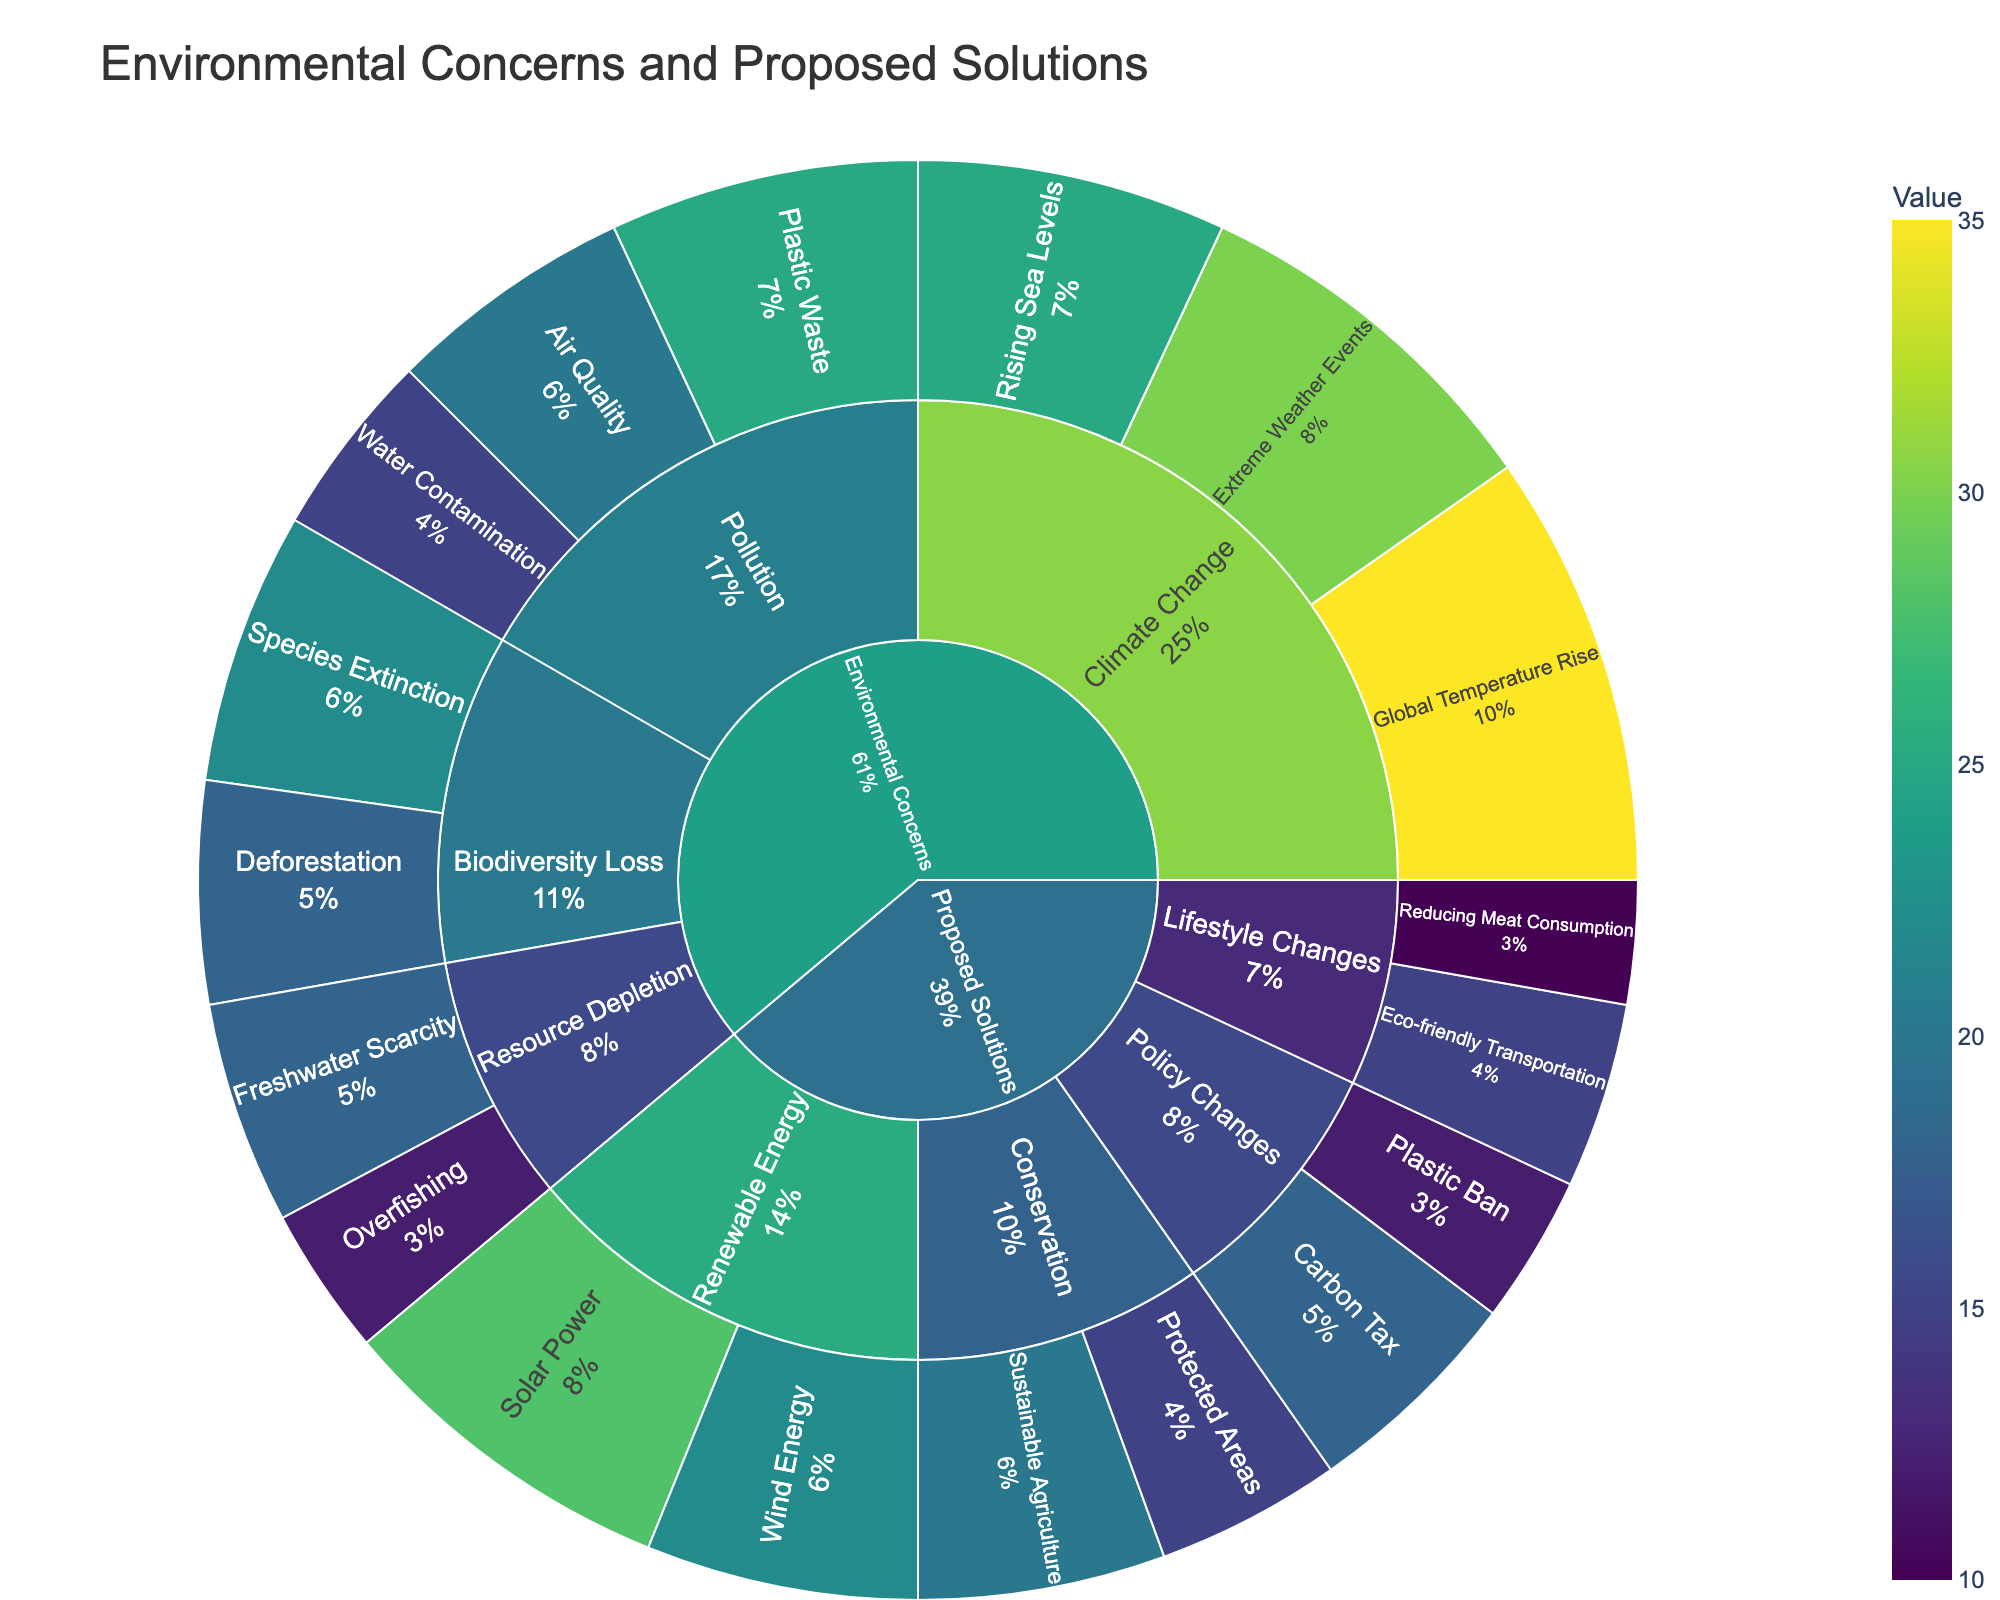What's the main topic in the central node? The Sunburst Plot's central node typically represents the highest-level category. Here, both 'Environmental Concerns' and 'Proposed Solutions' are shown, indicating these are the main overarching topics.
Answer: Environmental Concerns, Proposed Solutions Which issue under "Climate Change" has the highest value? Under the "Climate Change" subcategory, the "Global Temperature Rise" has the highest value noted on the Sunburst Plot.
Answer: Global Temperature Rise How many issues are represented under the "Pollution" subcategory? Visual inspection of the "Pollution" subcategory reveals that there are three issues: "Air Quality," "Water Contamination," and "Plastic Waste."
Answer: 3 What is the total value of the issues concerned with "Resource Depletion"? Issues under "Resource Depletion" include "Overfishing" and "Freshwater Scarcity." Summing up their values, we have 12 + 18 = 30.
Answer: 30 Among the proposed solutions, which category has the highest combined value? The proposed solutions can be categorized into "Renewable Energy," "Conservation," "Policy Changes," and "Lifestyle Changes." By summing values:
- Renewable Energy: 28 + 22 = 50
- Conservation: 15 + 20 = 35
- Policy Changes: 18 + 12 = 30
- Lifestyle Changes: 10 + 15 = 25
"Renewable Energy" has the highest combined value.
Answer: Renewable Energy What is the percentage contribution of "Extreme Weather Events" in the "Climate Change" subcategory? To find the percentage, divide the value of "Extreme Weather Events" by the total value of "Climate Change." Total value under "Climate Change" is 25 + 30 + 35 = 90. So, (30 / 90) * 100 = 33.33%.
Answer: 33.33% Compare the value of "Species Extinction" to "Deforestation" under "Biodiversity Loss." Which one is greater? Under "Biodiversity Loss," "Species Extinction" has a value of 22, while "Deforestation" has a value of 18. Thus, "Species Extinction" is greater.
Answer: Species Extinction What proposed solution has the lowest value? Among the proposed solutions, the lowest value is for "Reducing Meat Consumption" under "Lifestyle Changes," which has a value of 10.
Answer: Reducing Meat Consumption Which subcategory under "Proposed Solutions" has the smallest range of values? The subcategories and their value ranges:
- Renewable Energy: 28 - 22 = 6
- Conservation: 20 - 15 = 5
- Policy Changes: 18 - 12 = 6
- Lifestyle Changes: 15 - 10 = 5
Both "Conservation" and "Lifestyle Changes" have the smallest range of 5.
Answer: Conservation, Lifestyle Changes 